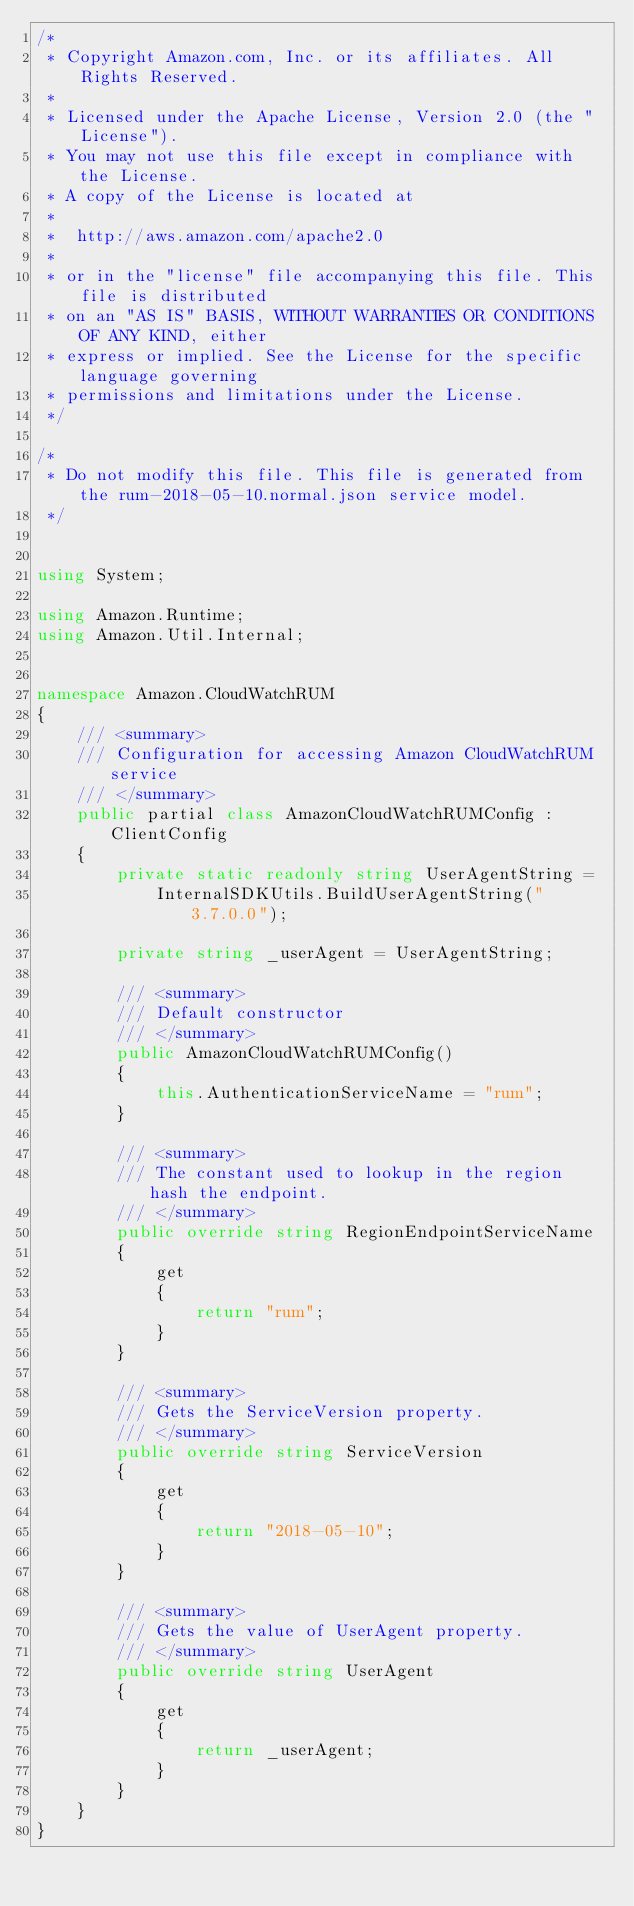<code> <loc_0><loc_0><loc_500><loc_500><_C#_>/*
 * Copyright Amazon.com, Inc. or its affiliates. All Rights Reserved.
 * 
 * Licensed under the Apache License, Version 2.0 (the "License").
 * You may not use this file except in compliance with the License.
 * A copy of the License is located at
 * 
 *  http://aws.amazon.com/apache2.0
 * 
 * or in the "license" file accompanying this file. This file is distributed
 * on an "AS IS" BASIS, WITHOUT WARRANTIES OR CONDITIONS OF ANY KIND, either
 * express or implied. See the License for the specific language governing
 * permissions and limitations under the License.
 */

/*
 * Do not modify this file. This file is generated from the rum-2018-05-10.normal.json service model.
 */


using System;

using Amazon.Runtime;
using Amazon.Util.Internal;


namespace Amazon.CloudWatchRUM
{
    /// <summary>
    /// Configuration for accessing Amazon CloudWatchRUM service
    /// </summary>
    public partial class AmazonCloudWatchRUMConfig : ClientConfig
    {
        private static readonly string UserAgentString =
            InternalSDKUtils.BuildUserAgentString("3.7.0.0");

        private string _userAgent = UserAgentString;

        /// <summary>
        /// Default constructor
        /// </summary>
        public AmazonCloudWatchRUMConfig()
        {
            this.AuthenticationServiceName = "rum";
        }

        /// <summary>
        /// The constant used to lookup in the region hash the endpoint.
        /// </summary>
        public override string RegionEndpointServiceName
        {
            get
            {
                return "rum";
            }
        }

        /// <summary>
        /// Gets the ServiceVersion property.
        /// </summary>
        public override string ServiceVersion
        {
            get
            {
                return "2018-05-10";
            }
        }

        /// <summary>
        /// Gets the value of UserAgent property.
        /// </summary>
        public override string UserAgent
        {
            get
            {
                return _userAgent;
            }
        }
    }
}</code> 